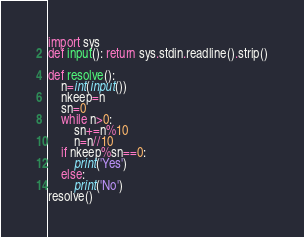Convert code to text. <code><loc_0><loc_0><loc_500><loc_500><_Python_>import sys
def input(): return sys.stdin.readline().strip()

def resolve():
    n=int(input())
    nkeep=n
    sn=0
    while n>0:
        sn+=n%10
        n=n//10
    if nkeep%sn==0:
        print('Yes')
    else:
        print('No')
resolve()</code> 